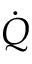<formula> <loc_0><loc_0><loc_500><loc_500>\dot { Q }</formula> 